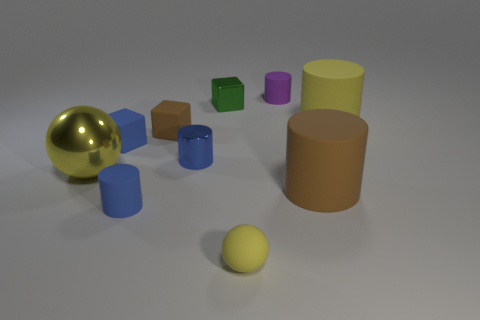There is a large cylinder that is the same color as the metal sphere; what material is it?
Your response must be concise. Rubber. Are any metallic objects visible?
Keep it short and to the point. Yes. What material is the brown thing that is the same shape as the small green object?
Your answer should be very brief. Rubber. There is a metal cylinder; are there any small blue things in front of it?
Give a very brief answer. Yes. Is the brown thing that is behind the big brown cylinder made of the same material as the small blue block?
Offer a terse response. Yes. Is there a big cylinder of the same color as the large sphere?
Your answer should be very brief. Yes. The tiny green metallic object has what shape?
Offer a very short reply. Cube. The rubber cylinder behind the large matte thing right of the big brown rubber cylinder is what color?
Make the answer very short. Purple. There is a matte cylinder that is behind the yellow cylinder; what is its size?
Your answer should be very brief. Small. Are there any large gray things made of the same material as the small green block?
Your answer should be very brief. No. 